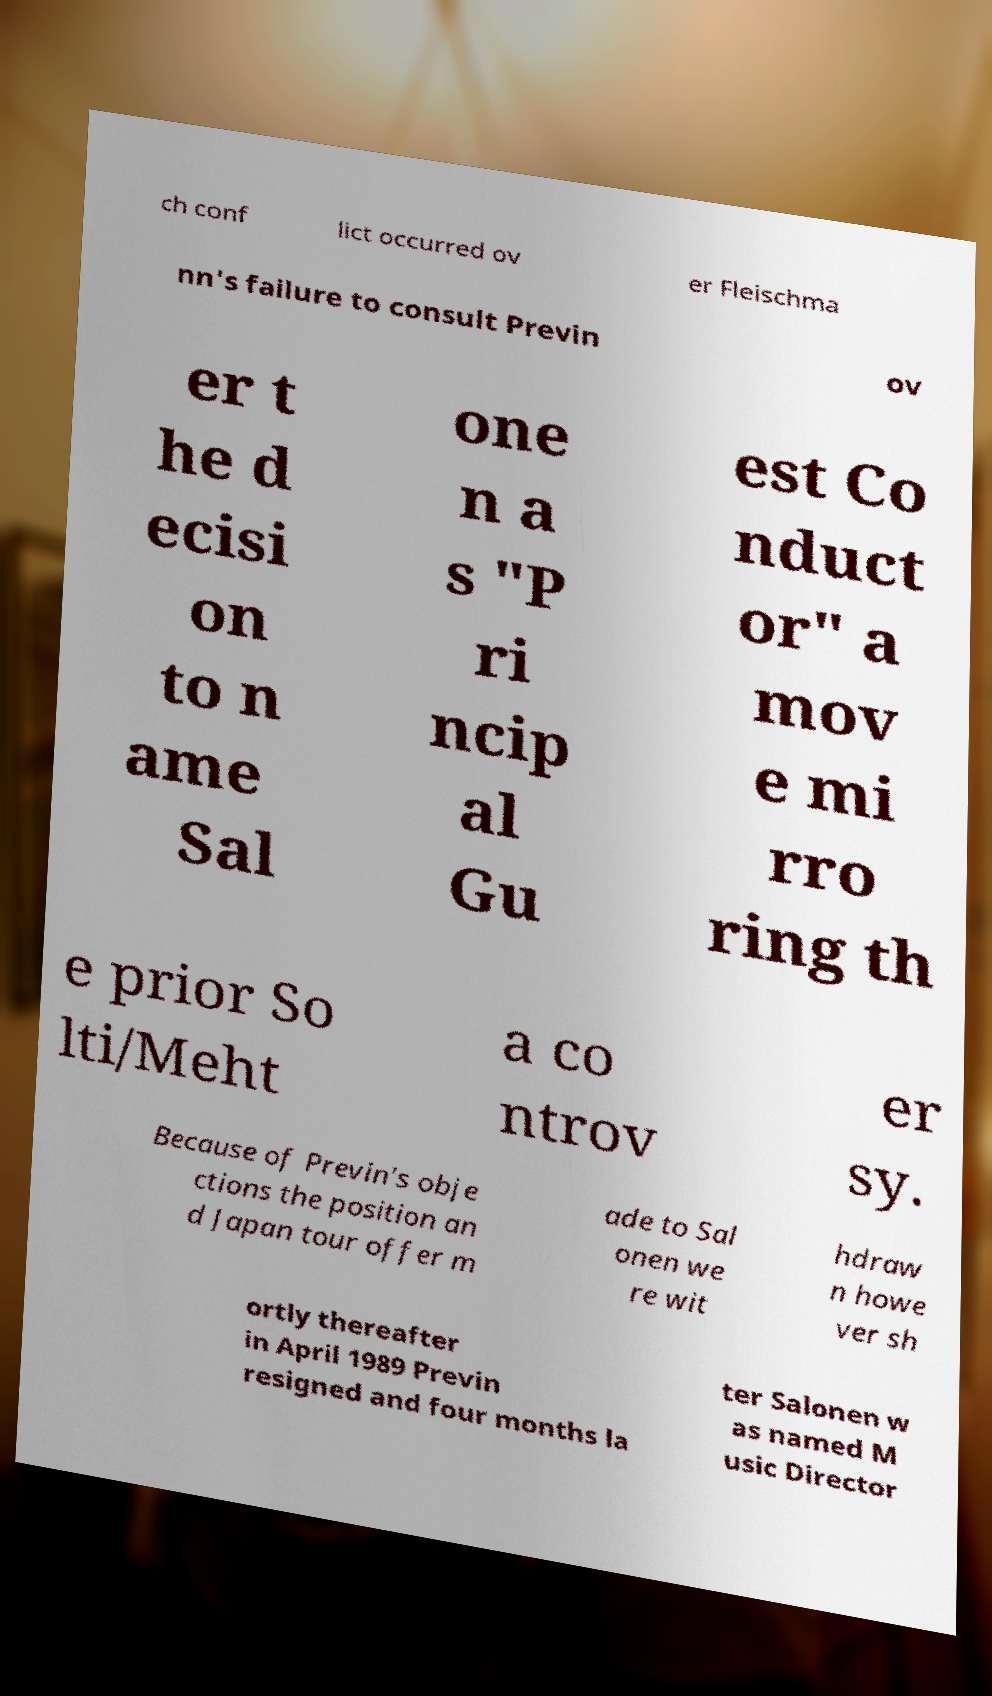Could you assist in decoding the text presented in this image and type it out clearly? ch conf lict occurred ov er Fleischma nn's failure to consult Previn ov er t he d ecisi on to n ame Sal one n a s "P ri ncip al Gu est Co nduct or" a mov e mi rro ring th e prior So lti/Meht a co ntrov er sy. Because of Previn's obje ctions the position an d Japan tour offer m ade to Sal onen we re wit hdraw n howe ver sh ortly thereafter in April 1989 Previn resigned and four months la ter Salonen w as named M usic Director 